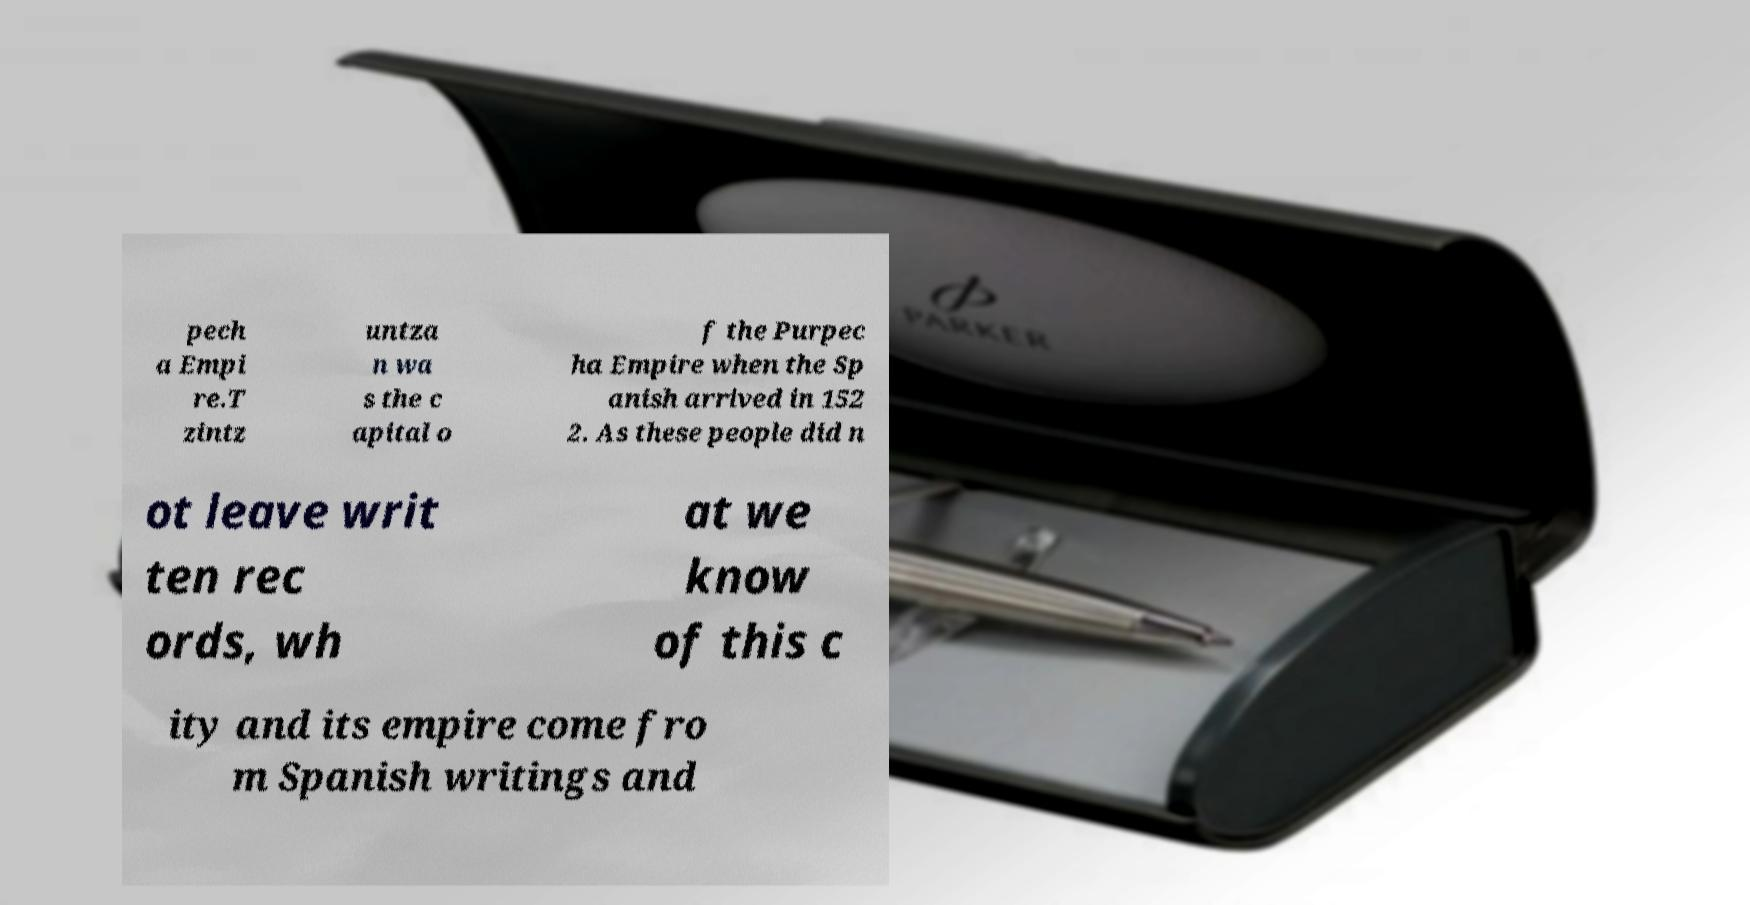What messages or text are displayed in this image? I need them in a readable, typed format. pech a Empi re.T zintz untza n wa s the c apital o f the Purpec ha Empire when the Sp anish arrived in 152 2. As these people did n ot leave writ ten rec ords, wh at we know of this c ity and its empire come fro m Spanish writings and 